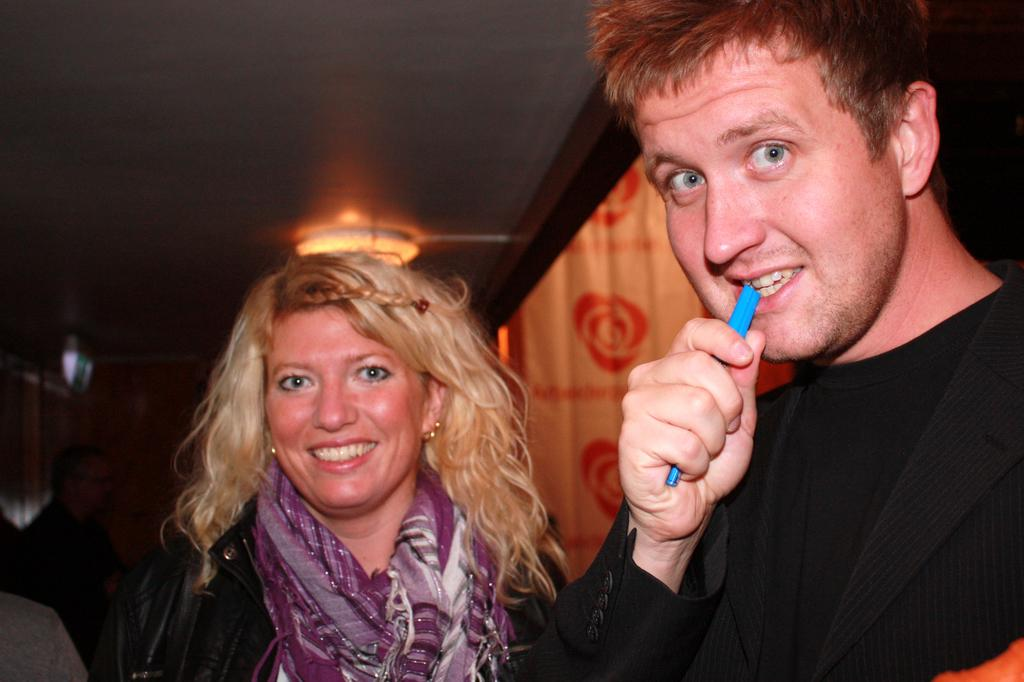How many people are visible in the image? There are two persons standing and smiling in the image. Are there any other people in the image besides the two main subjects? Yes, there are other people standing behind them. What is visible at the top of the image? There is a roof and light visible at the top of the image. How many frogs are sitting on the roof in the image? There are no frogs visible in the image; only people and a roof are present. What type of gold object is being held by the grandfather in the image? There is no grandfather or gold object present in the image. 